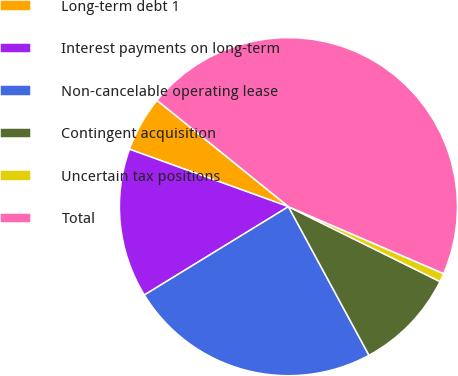<chart> <loc_0><loc_0><loc_500><loc_500><pie_chart><fcel>Long-term debt 1<fcel>Interest payments on long-term<fcel>Non-cancelable operating lease<fcel>Contingent acquisition<fcel>Uncertain tax positions<fcel>Total<nl><fcel>5.31%<fcel>14.27%<fcel>24.15%<fcel>9.79%<fcel>0.82%<fcel>45.66%<nl></chart> 